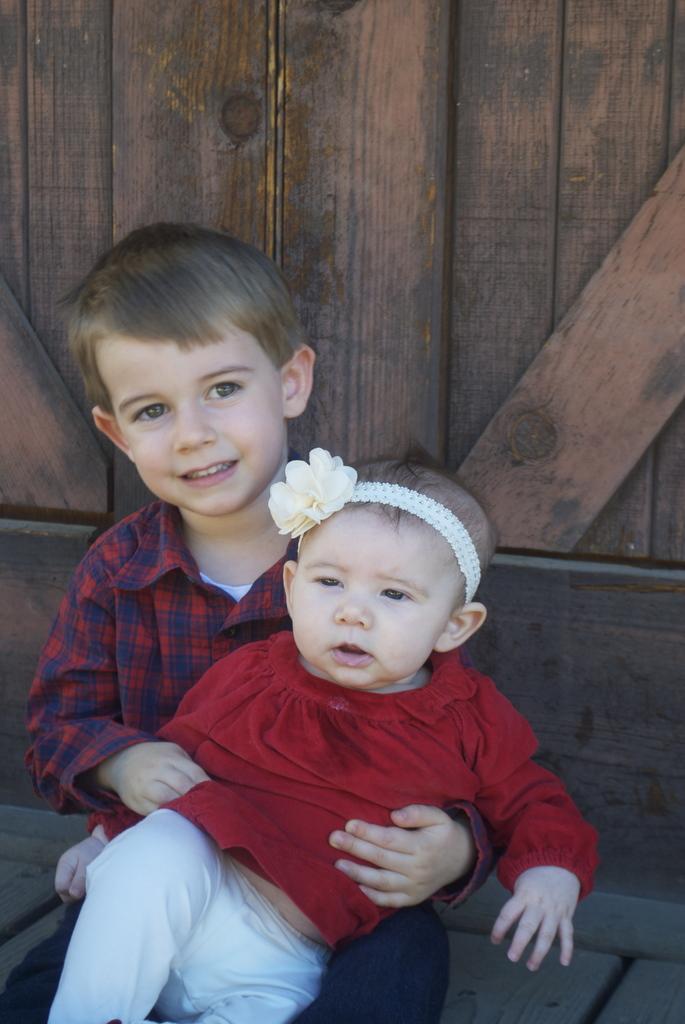Please provide a concise description of this image. In this picture we can see a boy. There is a baby sitting on this boy. We can see a wooden background. 